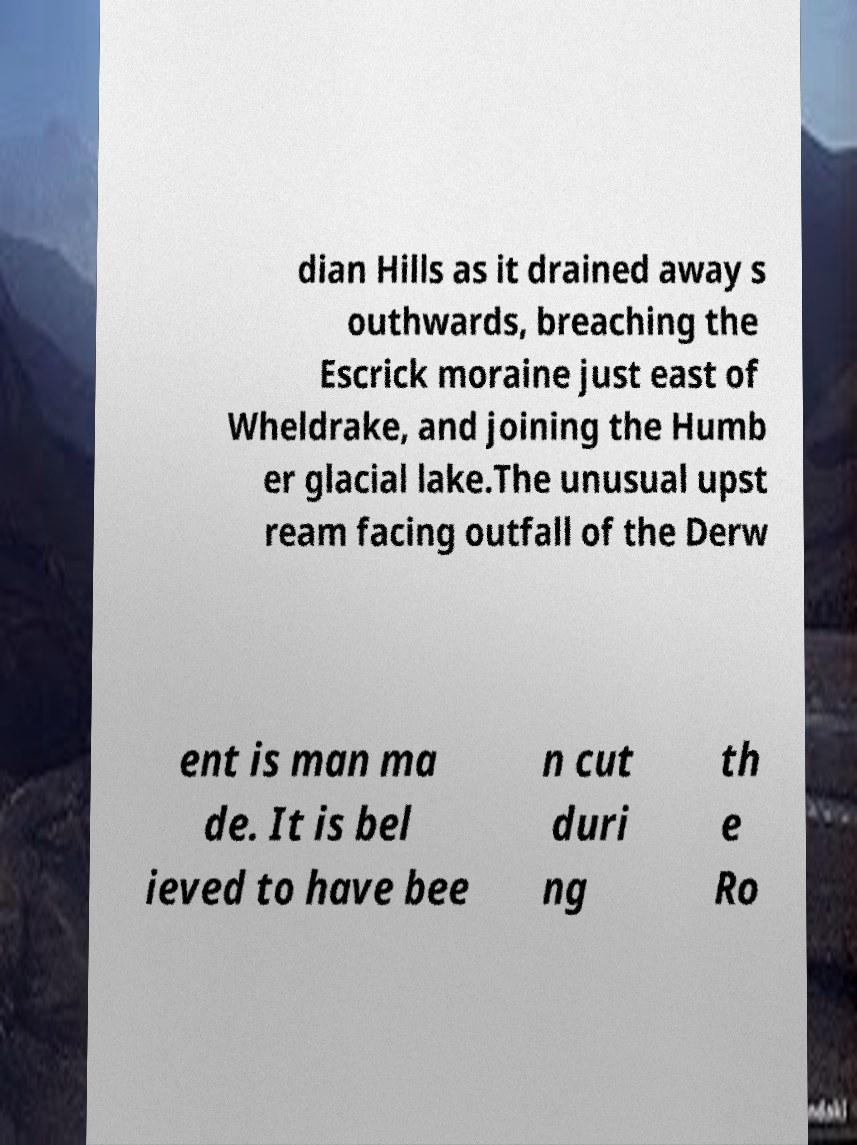Can you accurately transcribe the text from the provided image for me? dian Hills as it drained away s outhwards, breaching the Escrick moraine just east of Wheldrake, and joining the Humb er glacial lake.The unusual upst ream facing outfall of the Derw ent is man ma de. It is bel ieved to have bee n cut duri ng th e Ro 